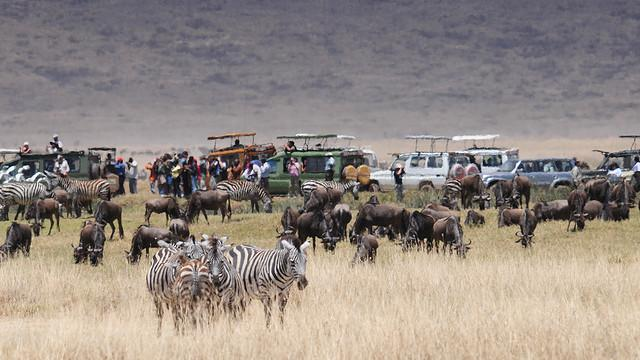What kind of animals are these in relation to their diets? herbivores 